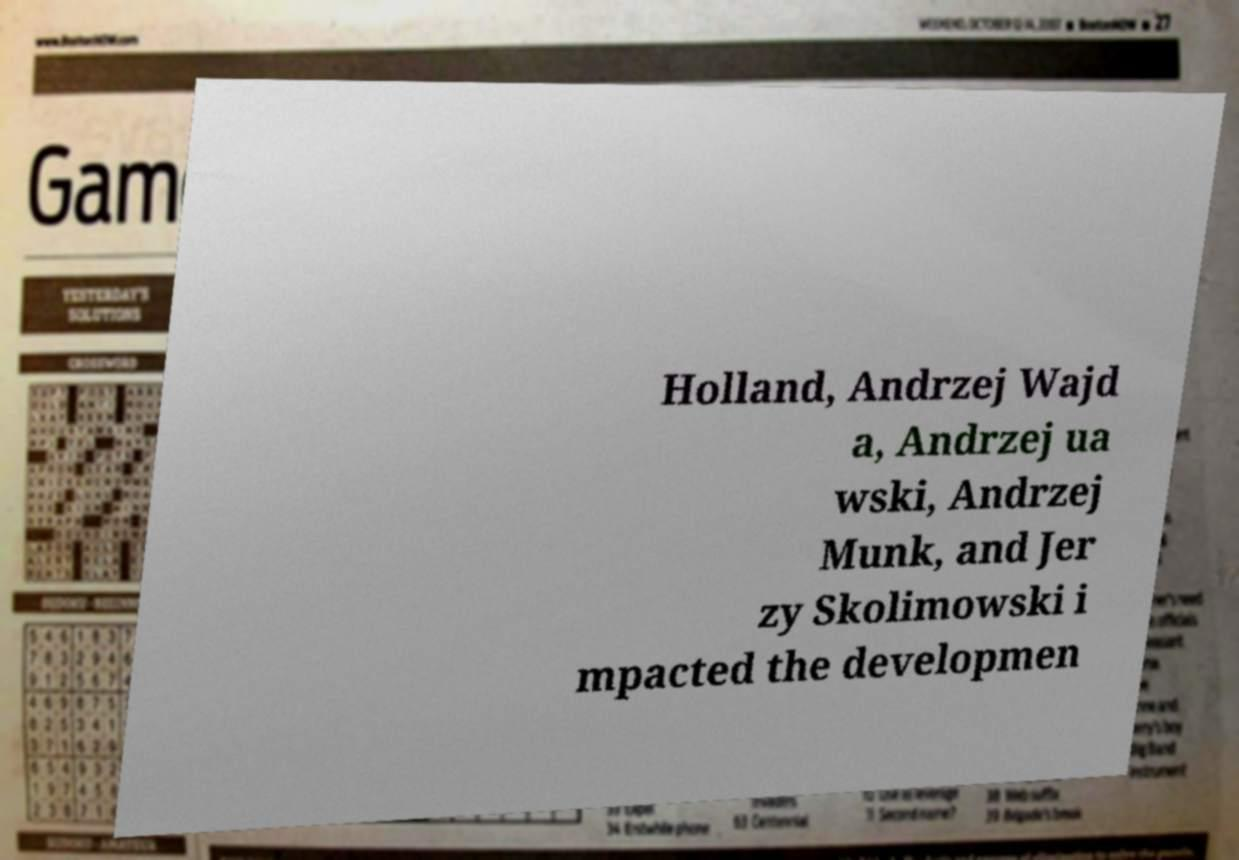Please identify and transcribe the text found in this image. Holland, Andrzej Wajd a, Andrzej ua wski, Andrzej Munk, and Jer zy Skolimowski i mpacted the developmen 